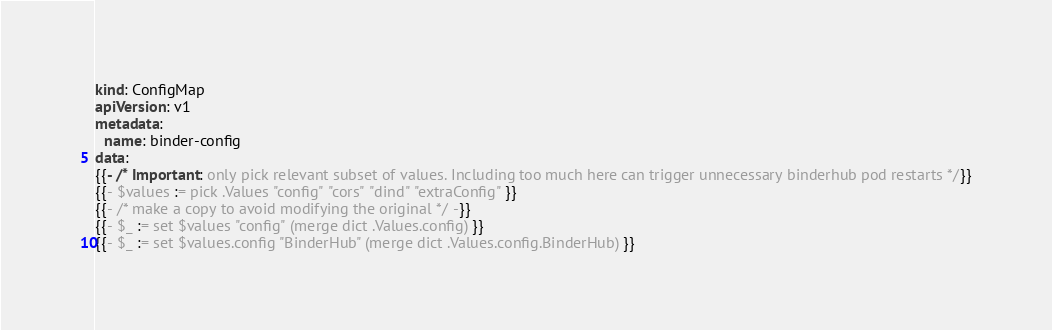<code> <loc_0><loc_0><loc_500><loc_500><_YAML_>kind: ConfigMap
apiVersion: v1
metadata:
  name: binder-config
data:
{{- /* Important: only pick relevant subset of values. Including too much here can trigger unnecessary binderhub pod restarts */}}
{{- $values := pick .Values "config" "cors" "dind" "extraConfig" }}
{{- /* make a copy to avoid modifying the original */ -}}
{{- $_ := set $values "config" (merge dict .Values.config) }}
{{- $_ := set $values.config "BinderHub" (merge dict .Values.config.BinderHub) }}</code> 